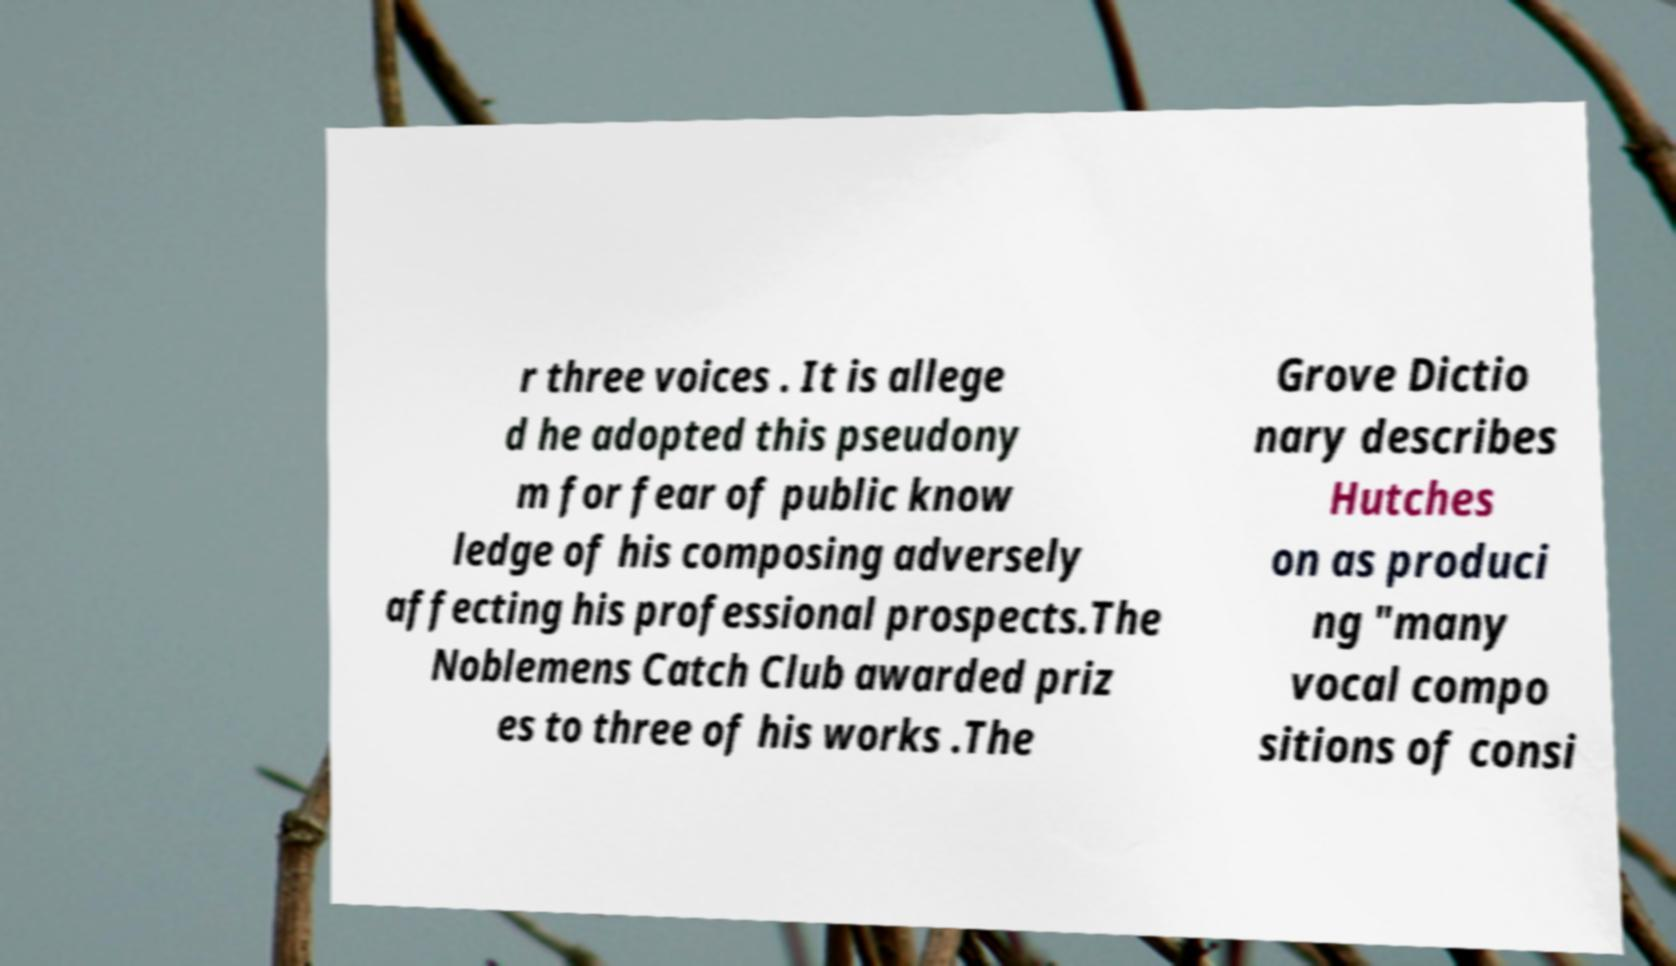There's text embedded in this image that I need extracted. Can you transcribe it verbatim? r three voices . It is allege d he adopted this pseudony m for fear of public know ledge of his composing adversely affecting his professional prospects.The Noblemens Catch Club awarded priz es to three of his works .The Grove Dictio nary describes Hutches on as produci ng "many vocal compo sitions of consi 